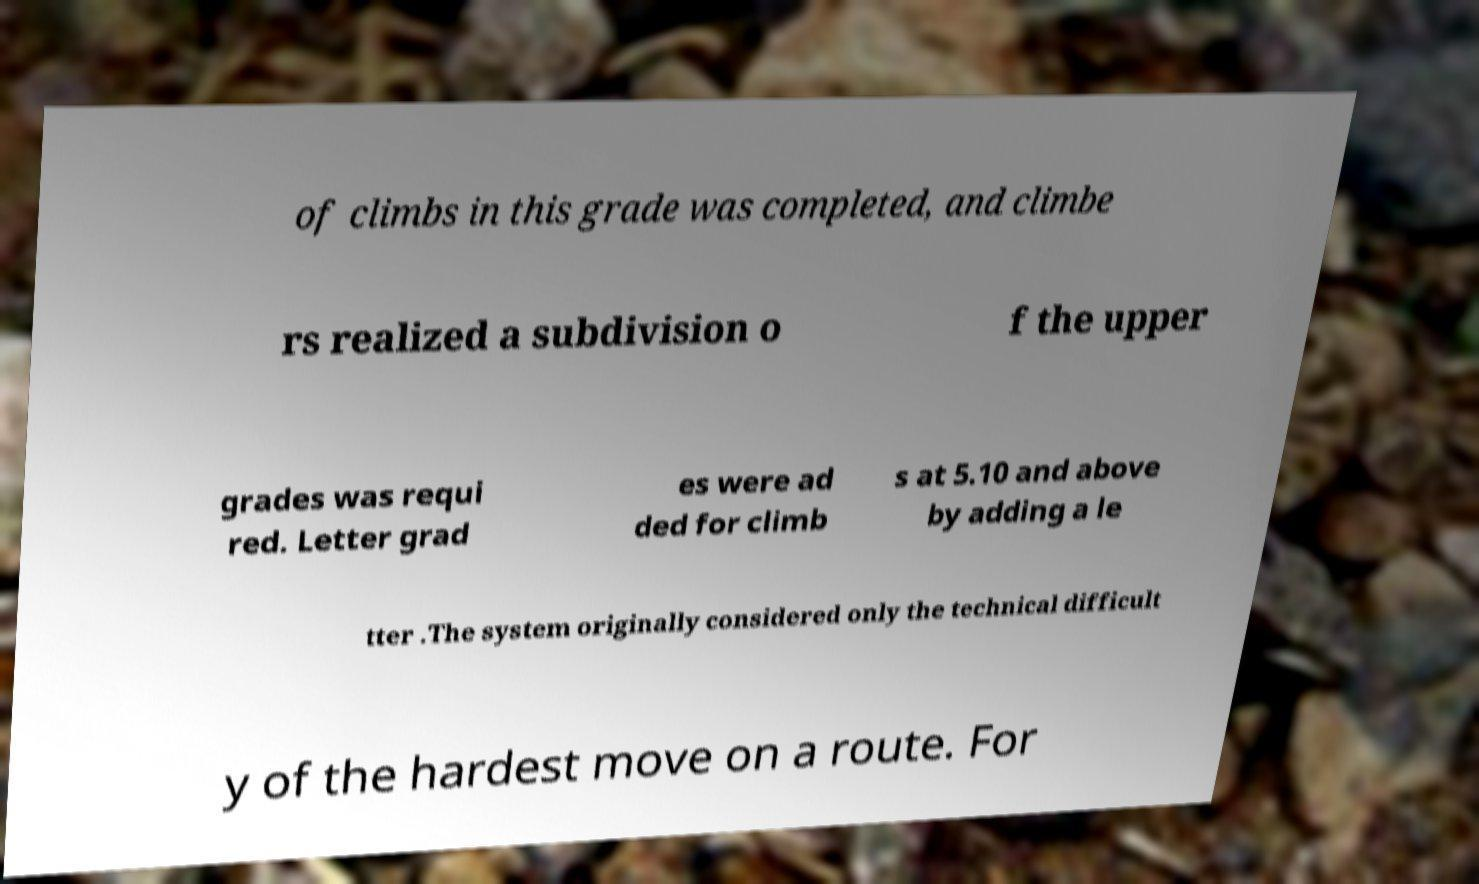Could you extract and type out the text from this image? of climbs in this grade was completed, and climbe rs realized a subdivision o f the upper grades was requi red. Letter grad es were ad ded for climb s at 5.10 and above by adding a le tter .The system originally considered only the technical difficult y of the hardest move on a route. For 